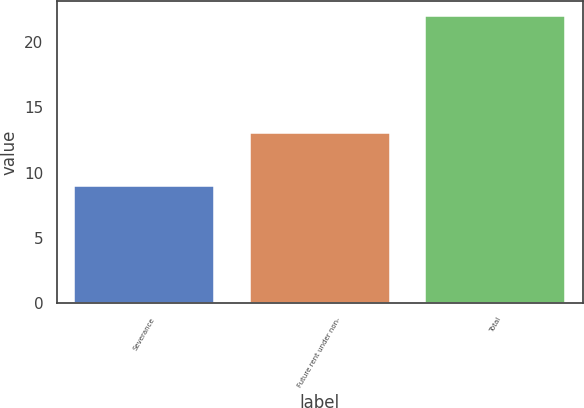<chart> <loc_0><loc_0><loc_500><loc_500><bar_chart><fcel>Severance<fcel>Future rent under non-<fcel>Total<nl><fcel>9<fcel>13<fcel>22<nl></chart> 